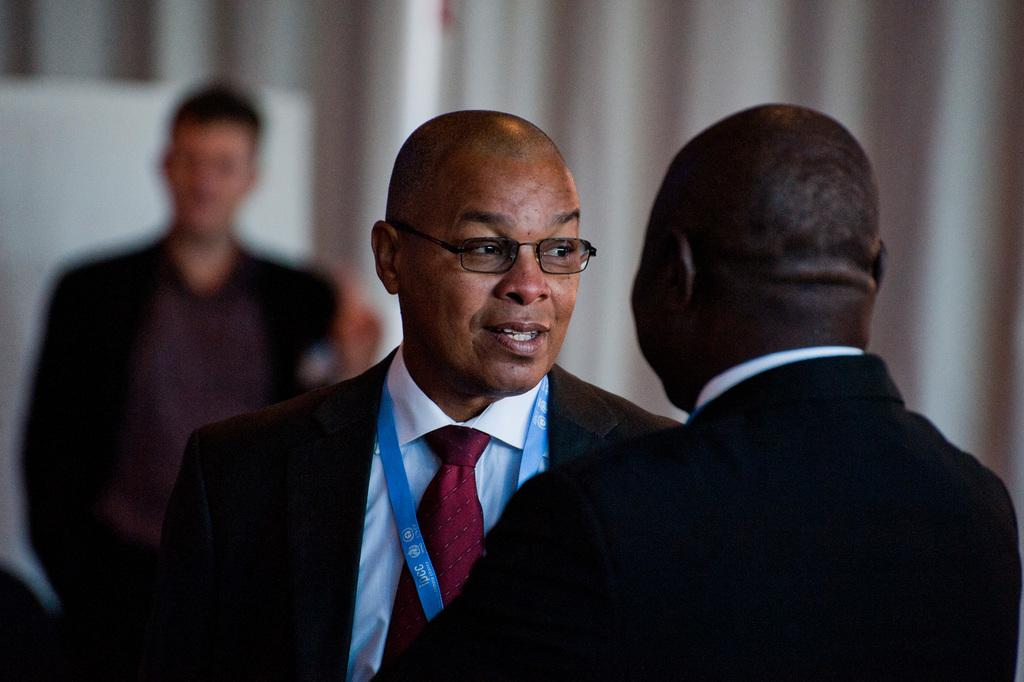How many people are in the center of the image? There are two persons standing in the center of the image. What is the facial expression of the two persons in the center? The two persons are smiling. What can be seen in the background of the image? There is a board and a curtain in the background of the image. Are there any other people visible in the image? Yes, there is one person standing in the background of the image. What type of oil is being used by the person in the image? There is no oil present in the image; it features two persons standing in the center and one person in the background. What record is being played by the person in the background? There is no record player or record visible in the image. 